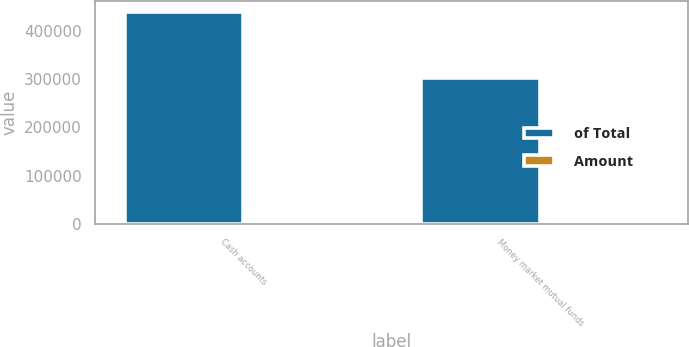Convert chart. <chart><loc_0><loc_0><loc_500><loc_500><stacked_bar_chart><ecel><fcel>Cash accounts<fcel>Money market mutual funds<nl><fcel>of Total<fcel>439348<fcel>303138<nl><fcel>Amount<fcel>59.2<fcel>40.8<nl></chart> 